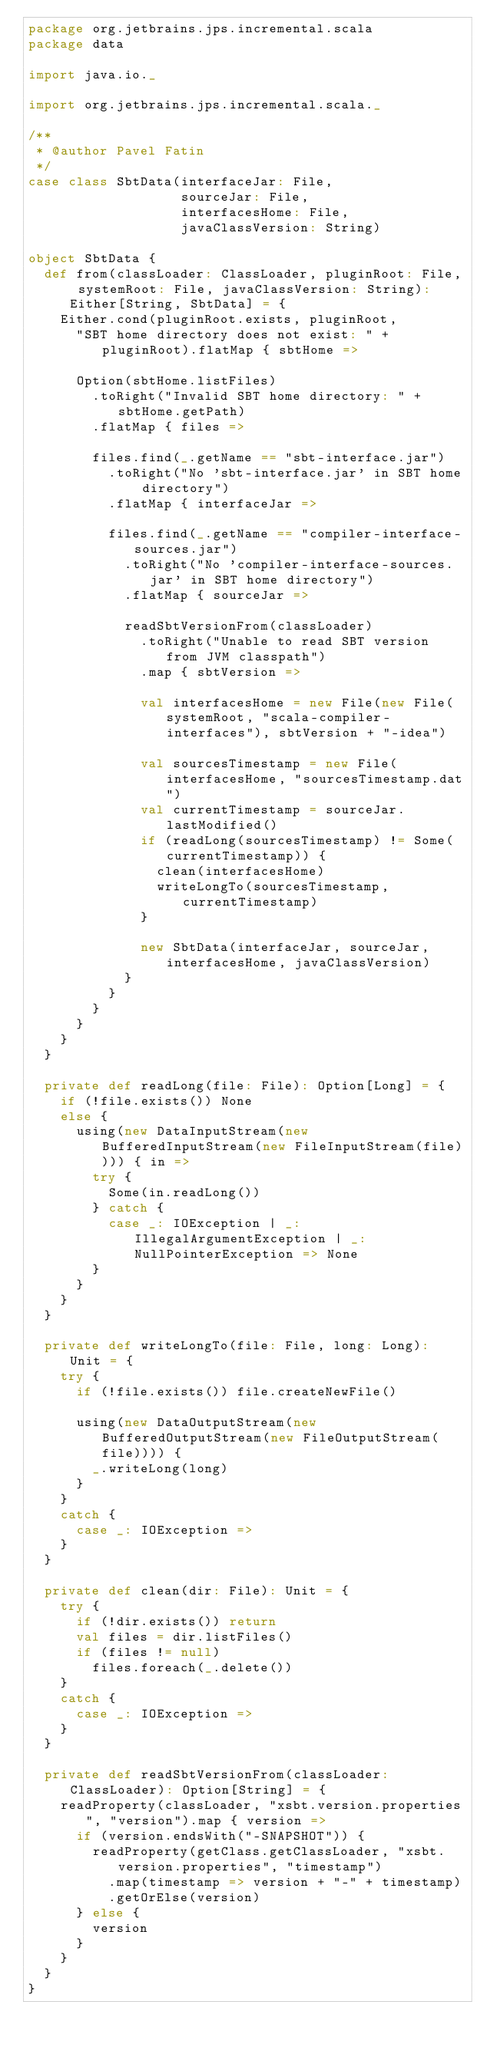Convert code to text. <code><loc_0><loc_0><loc_500><loc_500><_Scala_>package org.jetbrains.jps.incremental.scala
package data

import java.io._

import org.jetbrains.jps.incremental.scala._

/**
 * @author Pavel Fatin
 */
case class SbtData(interfaceJar: File,
                   sourceJar: File,
                   interfacesHome: File,
                   javaClassVersion: String)

object SbtData {
  def from(classLoader: ClassLoader, pluginRoot: File, systemRoot: File, javaClassVersion: String): Either[String, SbtData] = {
    Either.cond(pluginRoot.exists, pluginRoot,
      "SBT home directory does not exist: " + pluginRoot).flatMap { sbtHome =>

      Option(sbtHome.listFiles)
        .toRight("Invalid SBT home directory: " + sbtHome.getPath)
        .flatMap { files =>

        files.find(_.getName == "sbt-interface.jar")
          .toRight("No 'sbt-interface.jar' in SBT home directory")
          .flatMap { interfaceJar =>

          files.find(_.getName == "compiler-interface-sources.jar")
            .toRight("No 'compiler-interface-sources.jar' in SBT home directory")
            .flatMap { sourceJar =>

            readSbtVersionFrom(classLoader)
              .toRight("Unable to read SBT version from JVM classpath")
              .map { sbtVersion =>

              val interfacesHome = new File(new File(systemRoot, "scala-compiler-interfaces"), sbtVersion + "-idea")

              val sourcesTimestamp = new File(interfacesHome, "sourcesTimestamp.dat")
              val currentTimestamp = sourceJar.lastModified()
              if (readLong(sourcesTimestamp) != Some(currentTimestamp)) {
                clean(interfacesHome)
                writeLongTo(sourcesTimestamp, currentTimestamp)
              }

              new SbtData(interfaceJar, sourceJar, interfacesHome, javaClassVersion)
            }
          }
        }
      }
    }
  }

  private def readLong(file: File): Option[Long] = {
    if (!file.exists()) None
    else {
      using(new DataInputStream(new BufferedInputStream(new FileInputStream(file)))) { in =>
        try {
          Some(in.readLong())
        } catch {
          case _: IOException | _: IllegalArgumentException | _: NullPointerException => None
        }
      }
    }
  }

  private def writeLongTo(file: File, long: Long): Unit = {
    try {
      if (!file.exists()) file.createNewFile()

      using(new DataOutputStream(new BufferedOutputStream(new FileOutputStream(file)))) {
        _.writeLong(long)
      }
    }
    catch {
      case _: IOException =>
    }
  }

  private def clean(dir: File): Unit = {
    try {
      if (!dir.exists()) return
      val files = dir.listFiles()
      if (files != null)
        files.foreach(_.delete())
    }
    catch {
      case _: IOException =>
    }
  }

  private def readSbtVersionFrom(classLoader: ClassLoader): Option[String] = {
    readProperty(classLoader, "xsbt.version.properties", "version").map { version =>
      if (version.endsWith("-SNAPSHOT")) {
        readProperty(getClass.getClassLoader, "xsbt.version.properties", "timestamp")
          .map(timestamp => version + "-" + timestamp)
          .getOrElse(version)
      } else {
        version
      }
    }
  }
}
</code> 